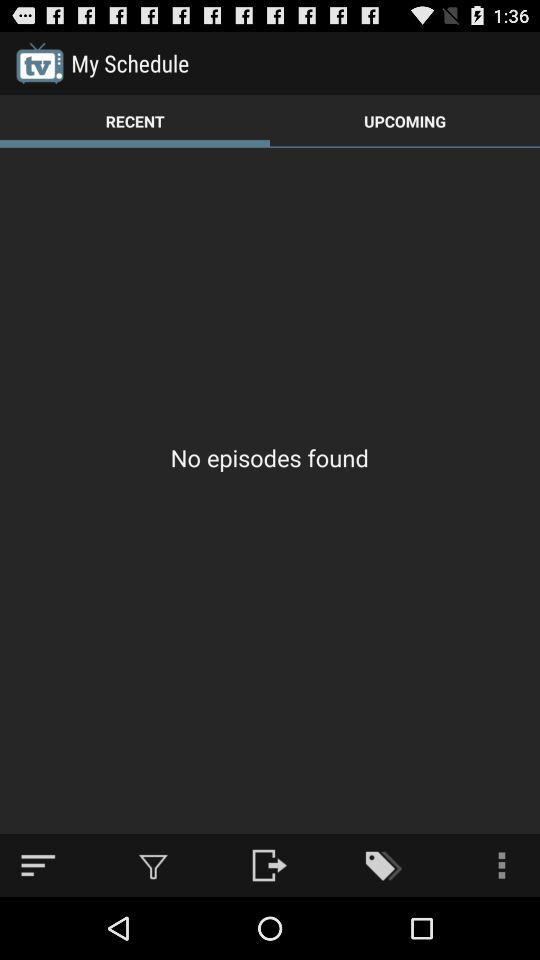Is there any episode found? There was no episode found. 